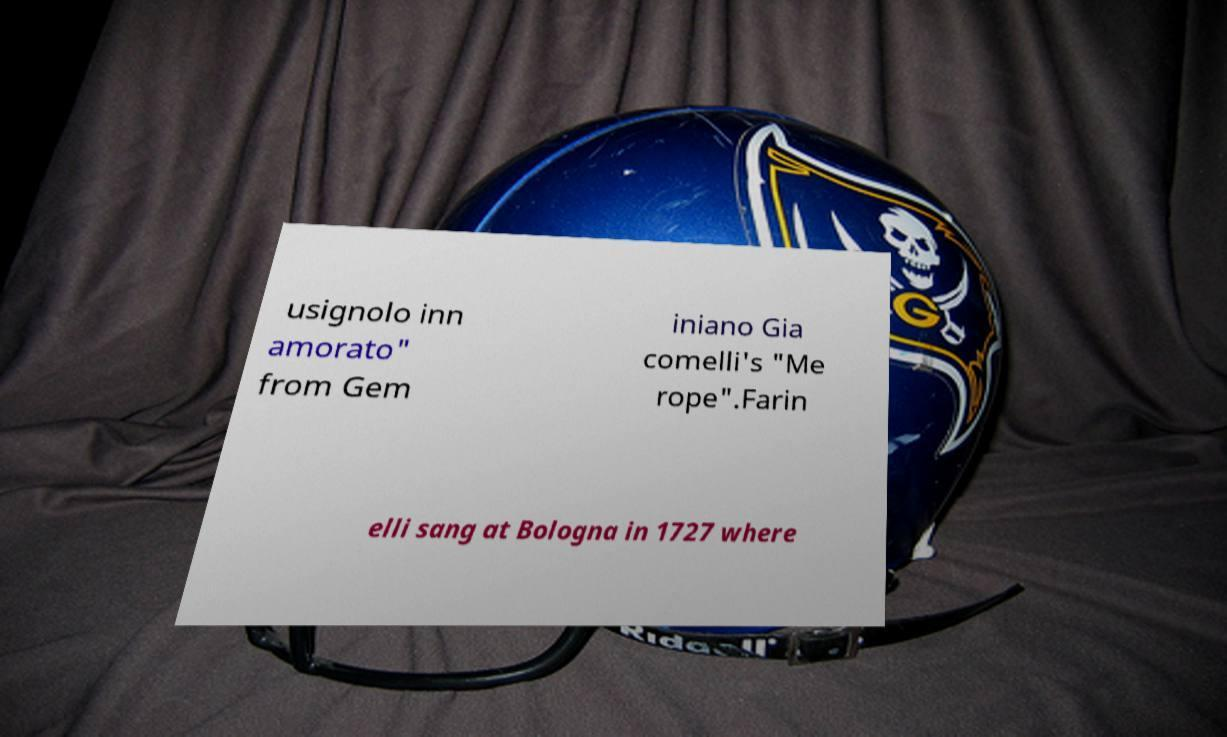Could you assist in decoding the text presented in this image and type it out clearly? usignolo inn amorato" from Gem iniano Gia comelli's "Me rope".Farin elli sang at Bologna in 1727 where 